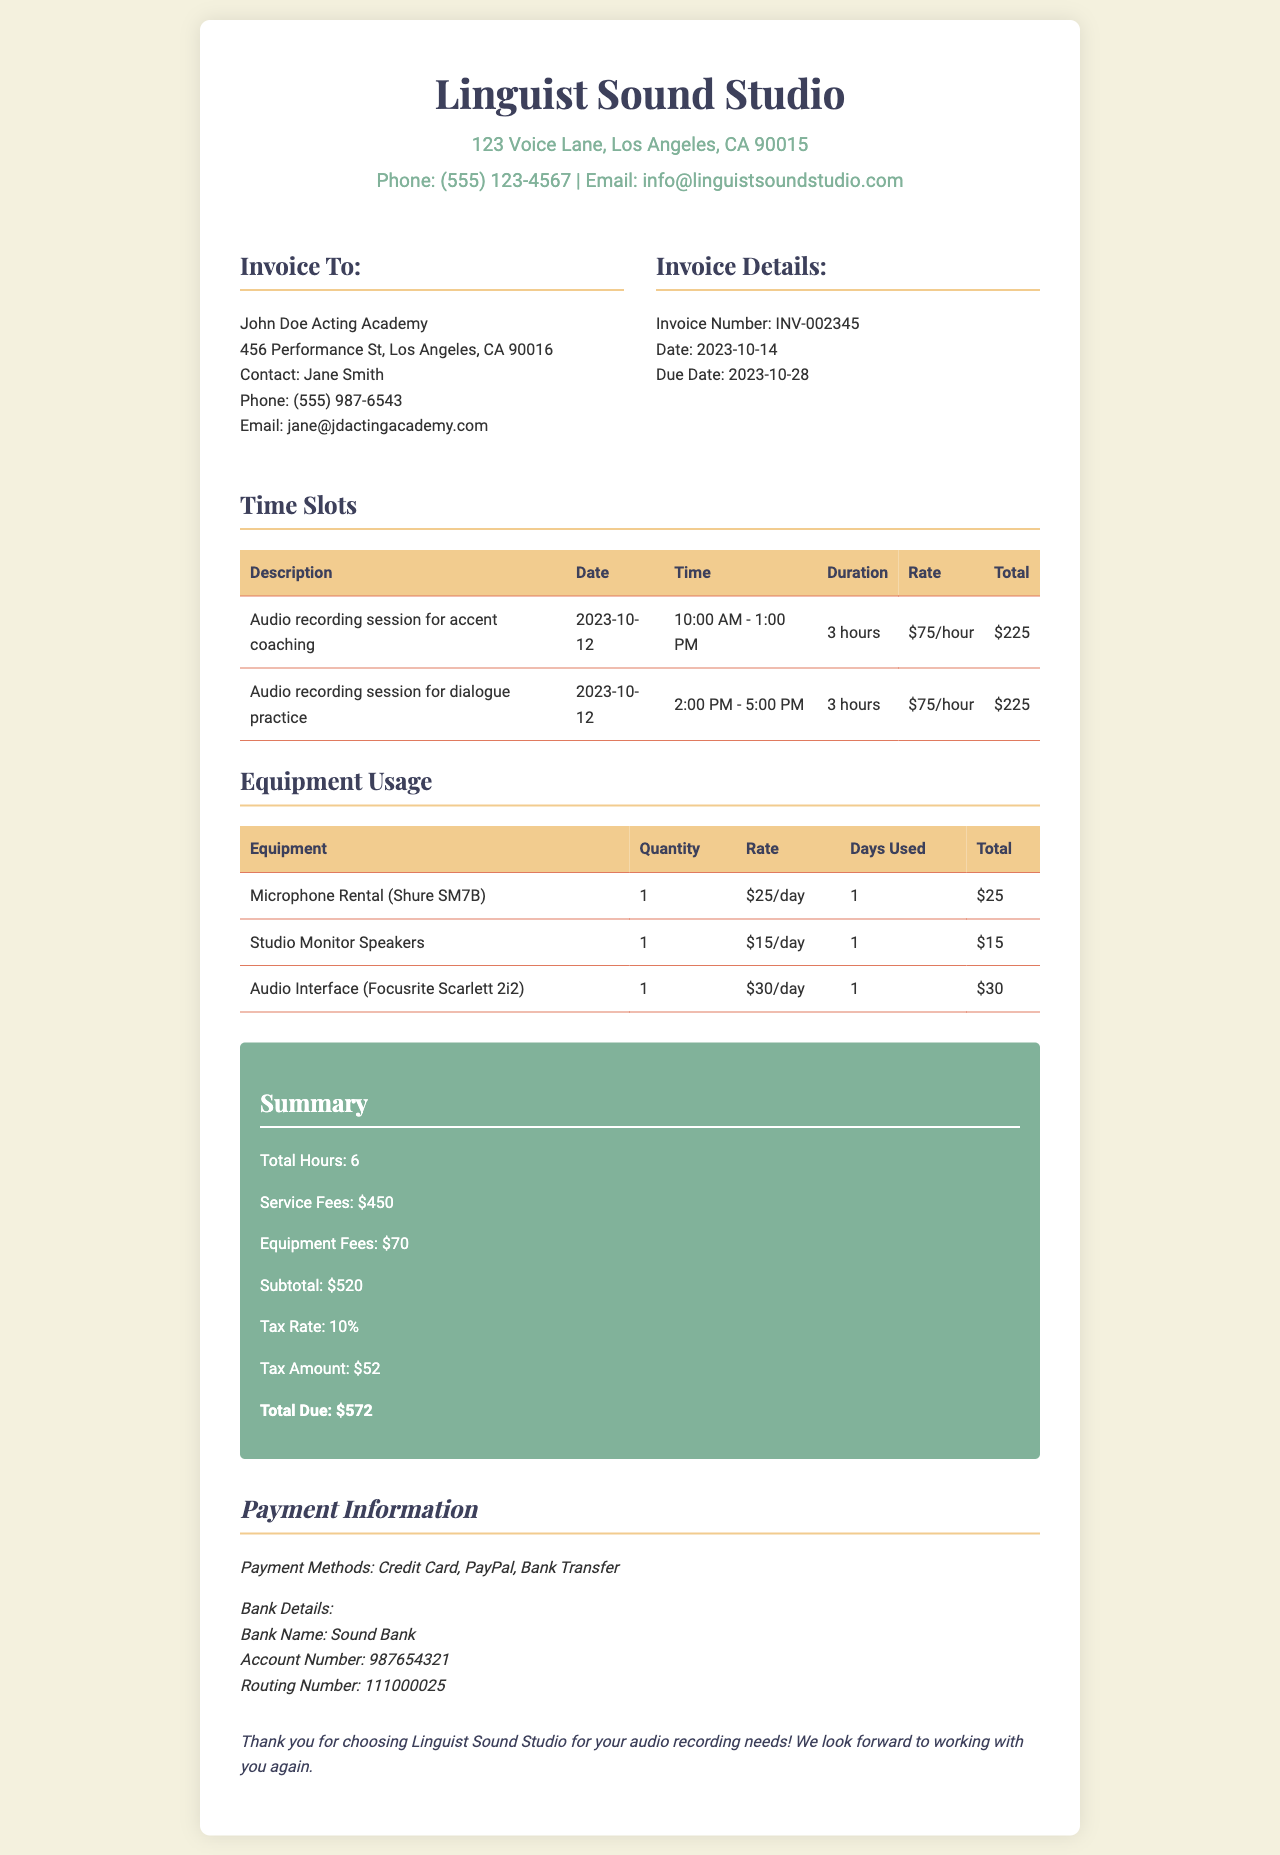What is the invoice number? The invoice number is listed under the invoice details section as INV-002345.
Answer: INV-002345 What is the total duration of the time slots reserved? The total duration is mentioned in the summary section as Total Hours: 6.
Answer: 6 Who is the contact person for the invoice recipient? The contact person is named Jane Smith, listed under the invoice recipient's details.
Answer: Jane Smith What is the total due amount? The total due amount is at the bottom of the summary section as Total Due: $572.
Answer: $572 How much is charged per hour for the audio recording sessions? The rate per hour is indicated in the time slots section as $75/hour.
Answer: $75/hour What equipment was rented for the audio session? The equipment rented is detailed in the equipment usage section and includes Microphone Rental, Studio Monitor Speakers, and Audio Interface.
Answer: Microphone Rental (Shure SM7B), Studio Monitor Speakers, Audio Interface (Focusrite Scarlett 2i2) What is the tax amount on the invoice? The tax amount is specified in the summary section as $52.
Answer: $52 How many days was the equipment used? The days used for each equipment item is listed in the equipment usage section as 1 day each.
Answer: 1 What is the rate for renting the microphone? The microphone rental rate is provided in the equipment usage section as $25/day.
Answer: $25/day 